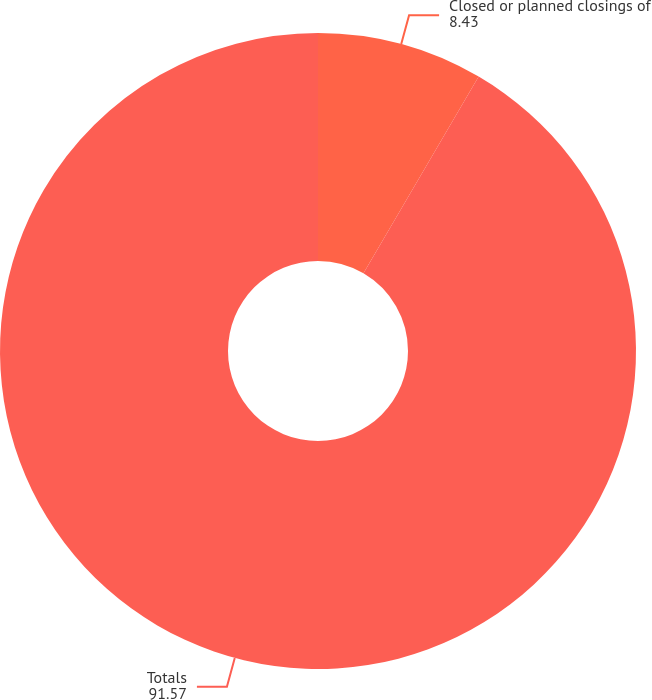Convert chart. <chart><loc_0><loc_0><loc_500><loc_500><pie_chart><fcel>Closed or planned closings of<fcel>Totals<nl><fcel>8.43%<fcel>91.57%<nl></chart> 